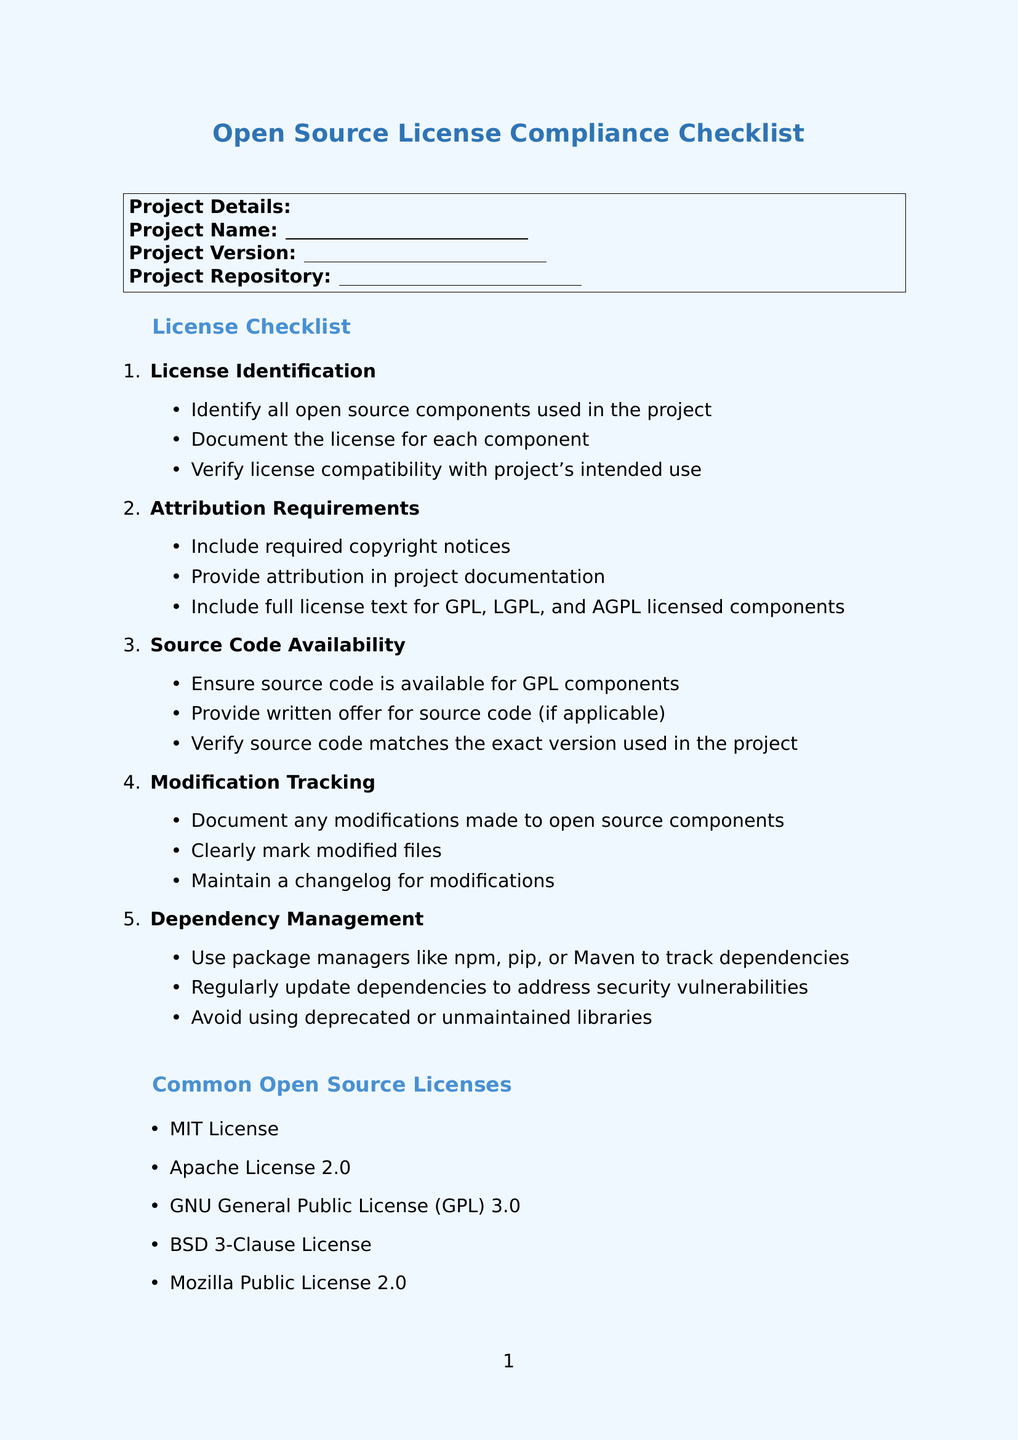What is the title of the document? The title of the document is the first major piece of information presented, which outlines its purpose.
Answer: Open Source License Compliance Checklist What is the first category in the license checklist? The categories in the checklist are organized in a specific order, and the first one is related to licensing.
Answer: License Identification Name one tool listed under Automation Tools. This document includes specific tools that help with license compliance, one of which is mentioned in the list.
Answer: FOSSA How many common open source licenses are listed? The document provides a list of commonly used open source licenses, and the quantity can be counted directly from that section.
Answer: Five What type of license does the GPL refer to? The section discussing licenses includes specific types and their abbreviations; identifying this requires knowledge of those terms.
Answer: General Public License What is the purpose of using package managers in dependency management? This section discusses strategies for managing dependencies, indicating the role of package managers in general terms.
Answer: Track dependencies Which online resource provides a list of licenses? This question seeks to identify a specific website mentioned in the online resources that serves a particular function.
Answer: Open Source Initiative What should be maintained for any modifications made? The checklist outlines documentation requirements concerning changes to components, specifying an important record-keeping practice.
Answer: Changelog How should modified files be marked? The requirements for marking files that have been altered are part of the checklist and indicate the need for clarity.
Answer: Clearly marked 